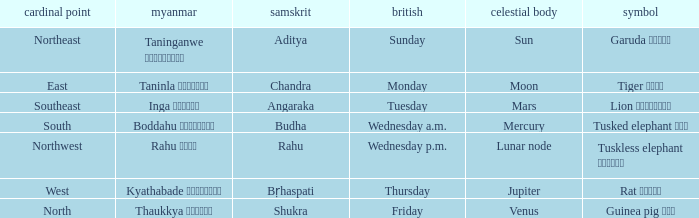What is the Burmese term for Thursday? Kyathabade ကြာသပတေး. 